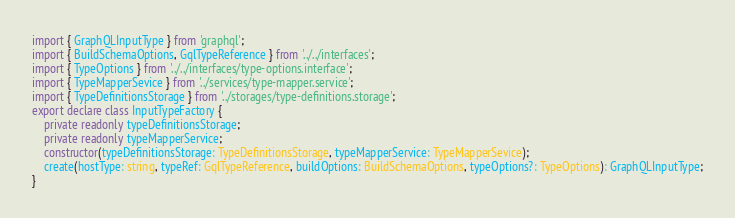Convert code to text. <code><loc_0><loc_0><loc_500><loc_500><_TypeScript_>import { GraphQLInputType } from 'graphql';
import { BuildSchemaOptions, GqlTypeReference } from '../../interfaces';
import { TypeOptions } from '../../interfaces/type-options.interface';
import { TypeMapperSevice } from '../services/type-mapper.service';
import { TypeDefinitionsStorage } from '../storages/type-definitions.storage';
export declare class InputTypeFactory {
    private readonly typeDefinitionsStorage;
    private readonly typeMapperService;
    constructor(typeDefinitionsStorage: TypeDefinitionsStorage, typeMapperService: TypeMapperSevice);
    create(hostType: string, typeRef: GqlTypeReference, buildOptions: BuildSchemaOptions, typeOptions?: TypeOptions): GraphQLInputType;
}
</code> 